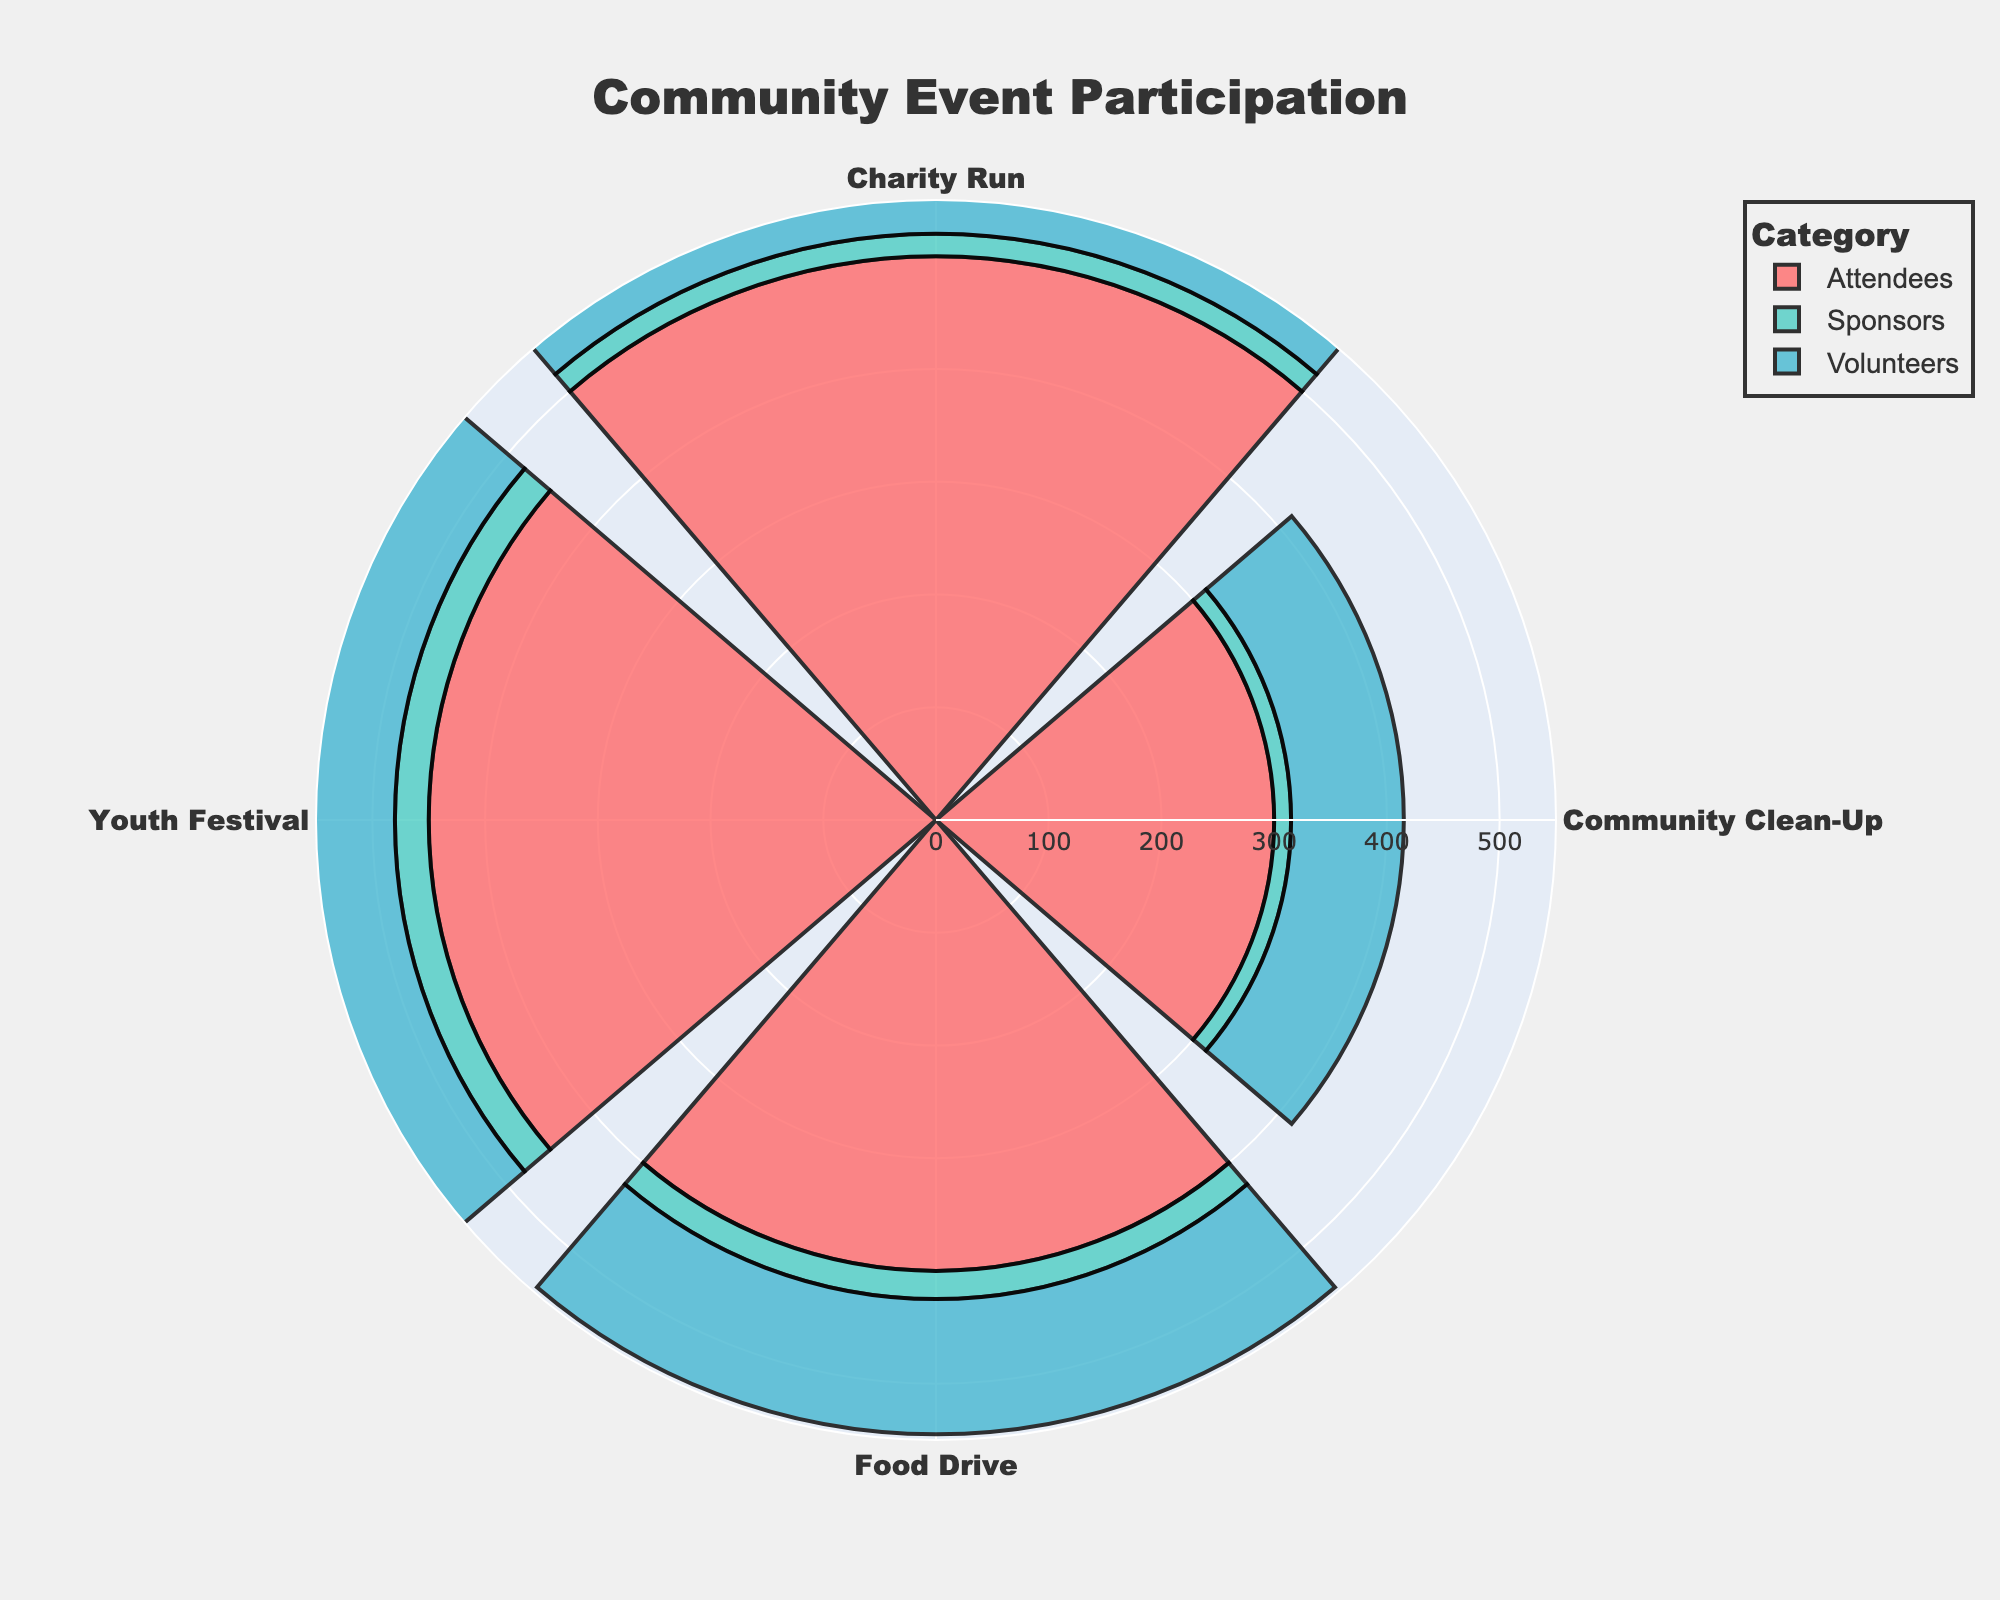What's the title of the figure? The title is displayed at the top center of the figure, indicating the overall theme or focus. Here the title is "Community Event Participation".
Answer: Community Event Participation How many engagement categories are shown in the rose chart? The rose chart includes a legend that displays the different engagement categories. By counting the items in the legend, we can determine there are three categories.
Answer: 3 Which event had the most attendees? Look at the segments corresponding to the "Attendees" category and compare their lengths. The longest segment indicates the event with the most attendees.
Answer: Charity Run How many total volunteers participated across all events? Add the volunteer counts for each event: 150 (Charity Run) + 100 (Community Clean-Up) + 120 (Food Drive) + 130 (Youth Festival).
Answer: 500 Which category has the lowest participation overall? Sum the counts for each category and compare them. Volunteers: 500, Attendees: 1650, Sponsors: 90. Sponsors have the lowest total participation.
Answer: Sponsors What is the difference in the number of attendees between the Charity Run and Community Clean-Up? Subtract the number of attendees for Community Clean-Up (300) from the number for Charity Run (500).
Answer: 200 Do any events have equal numbers of sponsors? Compare the sponsor counts for each event: Charity Run (20), Community Clean-Up (15), Food Drive (25), Youth Festival (30). None have equal numbers.
Answer: No Which event shows the highest total engagement (sum of all categories)? Sum the counts for each event: Charity Run (670), Community Clean-Up (415), Food Drive (545), Youth Festival (610). The Charity Run has the highest total engagement.
Answer: Charity Run 